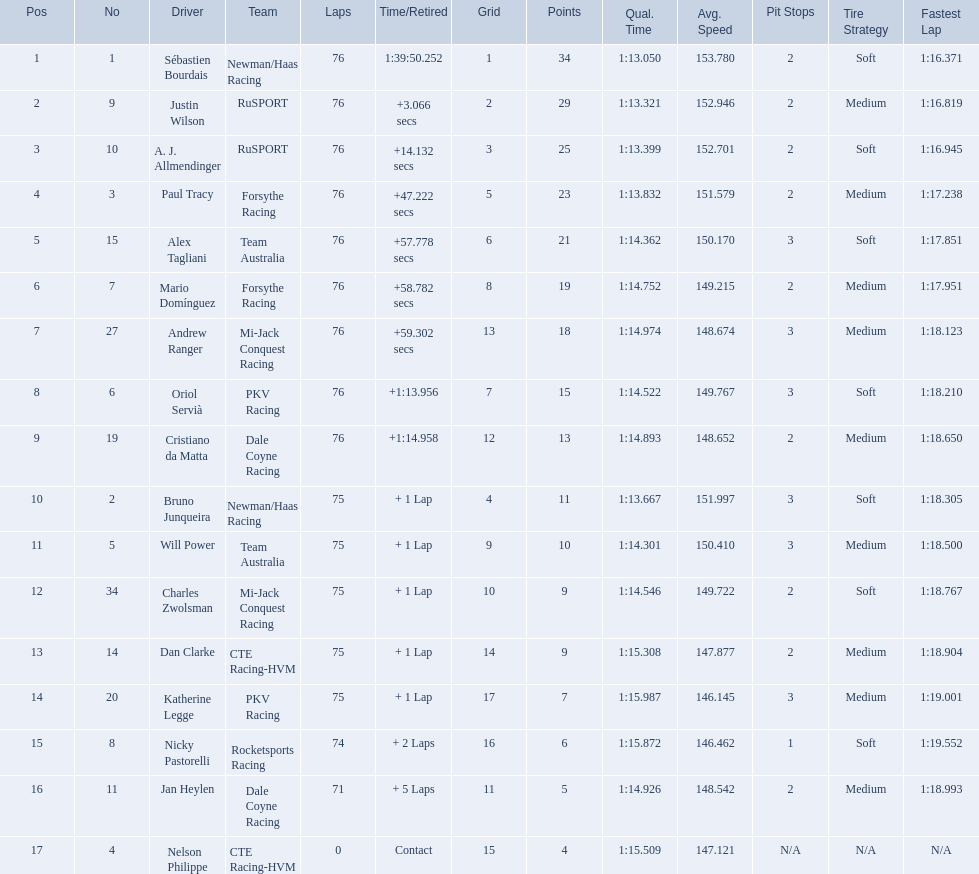How many points did charles zwolsman acquire? 9. Who else got 9 points? Dan Clarke. 